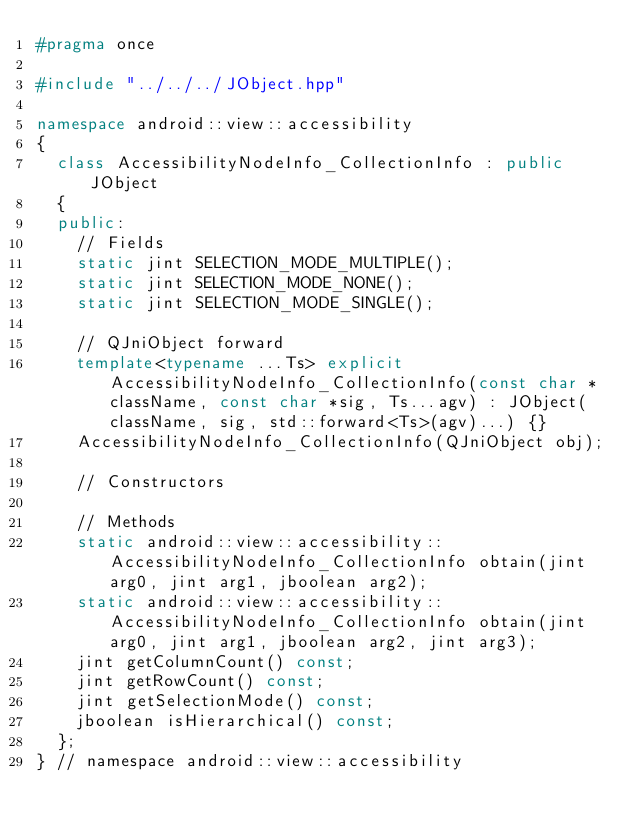<code> <loc_0><loc_0><loc_500><loc_500><_C++_>#pragma once

#include "../../../JObject.hpp"

namespace android::view::accessibility
{
	class AccessibilityNodeInfo_CollectionInfo : public JObject
	{
	public:
		// Fields
		static jint SELECTION_MODE_MULTIPLE();
		static jint SELECTION_MODE_NONE();
		static jint SELECTION_MODE_SINGLE();
		
		// QJniObject forward
		template<typename ...Ts> explicit AccessibilityNodeInfo_CollectionInfo(const char *className, const char *sig, Ts...agv) : JObject(className, sig, std::forward<Ts>(agv)...) {}
		AccessibilityNodeInfo_CollectionInfo(QJniObject obj);
		
		// Constructors
		
		// Methods
		static android::view::accessibility::AccessibilityNodeInfo_CollectionInfo obtain(jint arg0, jint arg1, jboolean arg2);
		static android::view::accessibility::AccessibilityNodeInfo_CollectionInfo obtain(jint arg0, jint arg1, jboolean arg2, jint arg3);
		jint getColumnCount() const;
		jint getRowCount() const;
		jint getSelectionMode() const;
		jboolean isHierarchical() const;
	};
} // namespace android::view::accessibility

</code> 